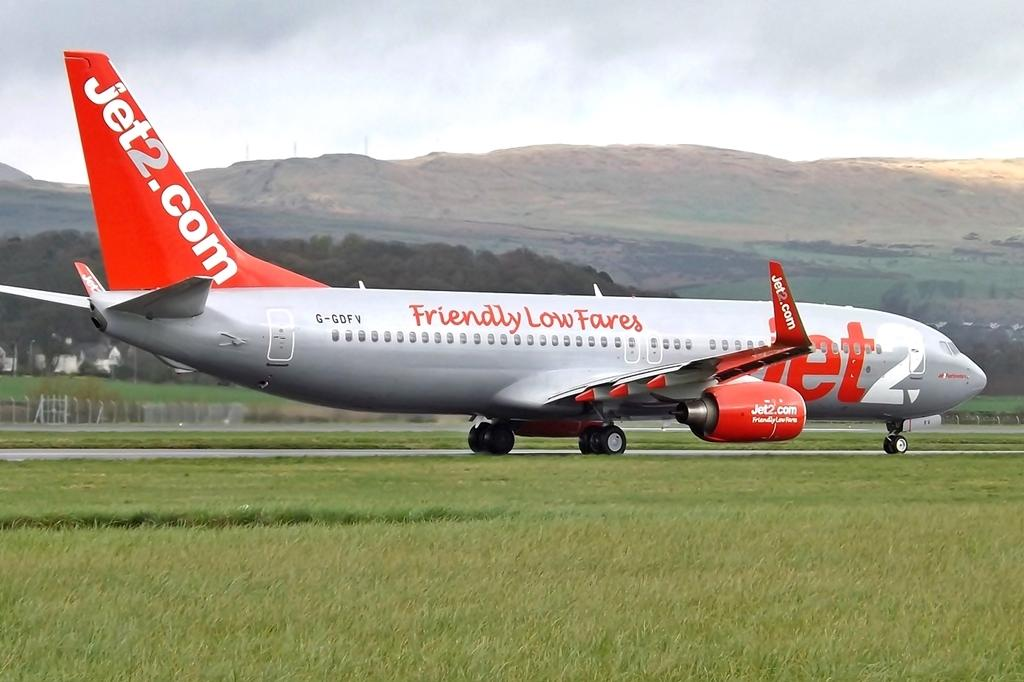<image>
Write a terse but informative summary of the picture. A silver plane has an orange tail with Jet2.com on it. 